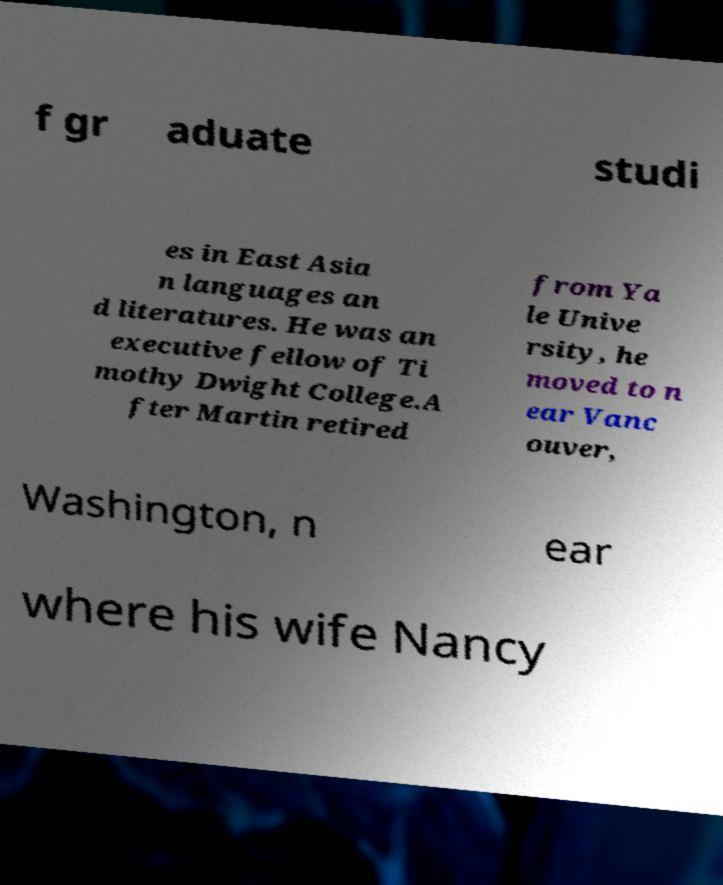Could you assist in decoding the text presented in this image and type it out clearly? f gr aduate studi es in East Asia n languages an d literatures. He was an executive fellow of Ti mothy Dwight College.A fter Martin retired from Ya le Unive rsity, he moved to n ear Vanc ouver, Washington, n ear where his wife Nancy 